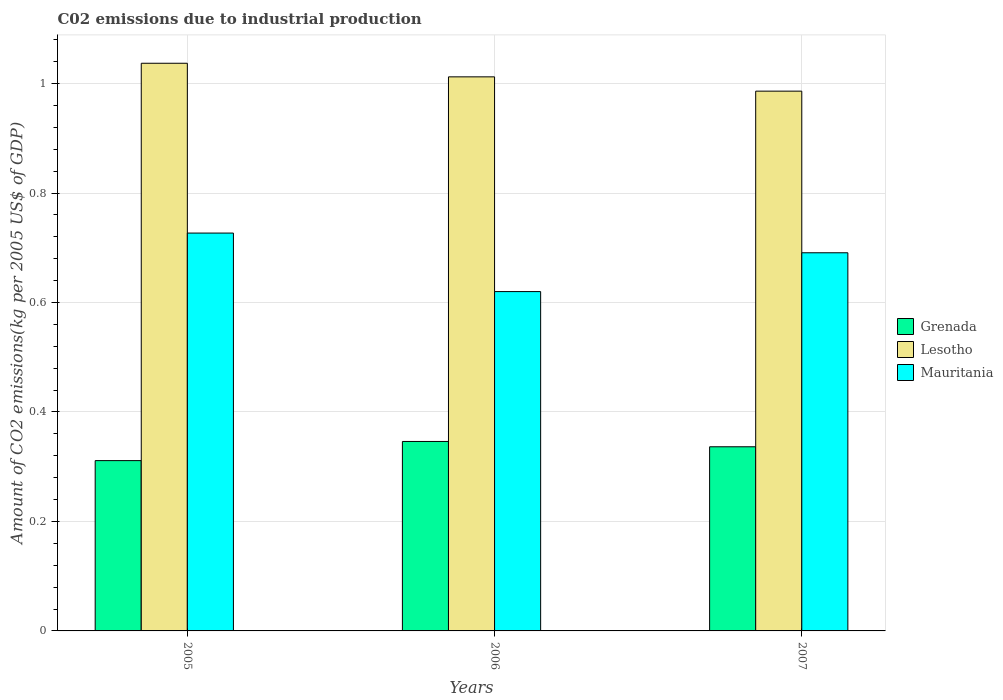How many different coloured bars are there?
Your response must be concise. 3. Are the number of bars on each tick of the X-axis equal?
Your response must be concise. Yes. How many bars are there on the 1st tick from the left?
Your response must be concise. 3. How many bars are there on the 2nd tick from the right?
Offer a terse response. 3. What is the label of the 2nd group of bars from the left?
Offer a terse response. 2006. What is the amount of CO2 emitted due to industrial production in Lesotho in 2006?
Your answer should be compact. 1.01. Across all years, what is the maximum amount of CO2 emitted due to industrial production in Lesotho?
Give a very brief answer. 1.04. Across all years, what is the minimum amount of CO2 emitted due to industrial production in Grenada?
Ensure brevity in your answer.  0.31. In which year was the amount of CO2 emitted due to industrial production in Lesotho maximum?
Your answer should be very brief. 2005. In which year was the amount of CO2 emitted due to industrial production in Grenada minimum?
Provide a succinct answer. 2005. What is the total amount of CO2 emitted due to industrial production in Grenada in the graph?
Provide a short and direct response. 0.99. What is the difference between the amount of CO2 emitted due to industrial production in Lesotho in 2005 and that in 2007?
Your answer should be very brief. 0.05. What is the difference between the amount of CO2 emitted due to industrial production in Lesotho in 2007 and the amount of CO2 emitted due to industrial production in Mauritania in 2005?
Ensure brevity in your answer.  0.26. What is the average amount of CO2 emitted due to industrial production in Grenada per year?
Your answer should be very brief. 0.33. In the year 2005, what is the difference between the amount of CO2 emitted due to industrial production in Grenada and amount of CO2 emitted due to industrial production in Mauritania?
Your answer should be very brief. -0.42. What is the ratio of the amount of CO2 emitted due to industrial production in Grenada in 2006 to that in 2007?
Keep it short and to the point. 1.03. Is the difference between the amount of CO2 emitted due to industrial production in Grenada in 2005 and 2007 greater than the difference between the amount of CO2 emitted due to industrial production in Mauritania in 2005 and 2007?
Offer a very short reply. No. What is the difference between the highest and the second highest amount of CO2 emitted due to industrial production in Grenada?
Your response must be concise. 0.01. What is the difference between the highest and the lowest amount of CO2 emitted due to industrial production in Lesotho?
Provide a succinct answer. 0.05. In how many years, is the amount of CO2 emitted due to industrial production in Grenada greater than the average amount of CO2 emitted due to industrial production in Grenada taken over all years?
Make the answer very short. 2. What does the 1st bar from the left in 2006 represents?
Your answer should be compact. Grenada. What does the 2nd bar from the right in 2007 represents?
Your response must be concise. Lesotho. How many bars are there?
Keep it short and to the point. 9. What is the difference between two consecutive major ticks on the Y-axis?
Offer a very short reply. 0.2. Are the values on the major ticks of Y-axis written in scientific E-notation?
Your answer should be very brief. No. Does the graph contain any zero values?
Offer a terse response. No. What is the title of the graph?
Give a very brief answer. C02 emissions due to industrial production. What is the label or title of the Y-axis?
Make the answer very short. Amount of CO2 emissions(kg per 2005 US$ of GDP). What is the Amount of CO2 emissions(kg per 2005 US$ of GDP) of Grenada in 2005?
Keep it short and to the point. 0.31. What is the Amount of CO2 emissions(kg per 2005 US$ of GDP) in Lesotho in 2005?
Ensure brevity in your answer.  1.04. What is the Amount of CO2 emissions(kg per 2005 US$ of GDP) in Mauritania in 2005?
Your answer should be compact. 0.73. What is the Amount of CO2 emissions(kg per 2005 US$ of GDP) in Grenada in 2006?
Keep it short and to the point. 0.35. What is the Amount of CO2 emissions(kg per 2005 US$ of GDP) in Lesotho in 2006?
Offer a very short reply. 1.01. What is the Amount of CO2 emissions(kg per 2005 US$ of GDP) of Mauritania in 2006?
Provide a succinct answer. 0.62. What is the Amount of CO2 emissions(kg per 2005 US$ of GDP) in Grenada in 2007?
Your answer should be compact. 0.34. What is the Amount of CO2 emissions(kg per 2005 US$ of GDP) of Lesotho in 2007?
Offer a very short reply. 0.99. What is the Amount of CO2 emissions(kg per 2005 US$ of GDP) of Mauritania in 2007?
Offer a very short reply. 0.69. Across all years, what is the maximum Amount of CO2 emissions(kg per 2005 US$ of GDP) in Grenada?
Your answer should be very brief. 0.35. Across all years, what is the maximum Amount of CO2 emissions(kg per 2005 US$ of GDP) in Lesotho?
Offer a terse response. 1.04. Across all years, what is the maximum Amount of CO2 emissions(kg per 2005 US$ of GDP) in Mauritania?
Your response must be concise. 0.73. Across all years, what is the minimum Amount of CO2 emissions(kg per 2005 US$ of GDP) in Grenada?
Your answer should be compact. 0.31. Across all years, what is the minimum Amount of CO2 emissions(kg per 2005 US$ of GDP) in Lesotho?
Your response must be concise. 0.99. Across all years, what is the minimum Amount of CO2 emissions(kg per 2005 US$ of GDP) of Mauritania?
Make the answer very short. 0.62. What is the total Amount of CO2 emissions(kg per 2005 US$ of GDP) in Lesotho in the graph?
Your answer should be compact. 3.04. What is the total Amount of CO2 emissions(kg per 2005 US$ of GDP) of Mauritania in the graph?
Provide a succinct answer. 2.04. What is the difference between the Amount of CO2 emissions(kg per 2005 US$ of GDP) in Grenada in 2005 and that in 2006?
Your answer should be very brief. -0.04. What is the difference between the Amount of CO2 emissions(kg per 2005 US$ of GDP) in Lesotho in 2005 and that in 2006?
Provide a succinct answer. 0.02. What is the difference between the Amount of CO2 emissions(kg per 2005 US$ of GDP) in Mauritania in 2005 and that in 2006?
Give a very brief answer. 0.11. What is the difference between the Amount of CO2 emissions(kg per 2005 US$ of GDP) of Grenada in 2005 and that in 2007?
Offer a terse response. -0.03. What is the difference between the Amount of CO2 emissions(kg per 2005 US$ of GDP) in Lesotho in 2005 and that in 2007?
Give a very brief answer. 0.05. What is the difference between the Amount of CO2 emissions(kg per 2005 US$ of GDP) of Mauritania in 2005 and that in 2007?
Your answer should be compact. 0.04. What is the difference between the Amount of CO2 emissions(kg per 2005 US$ of GDP) in Grenada in 2006 and that in 2007?
Keep it short and to the point. 0.01. What is the difference between the Amount of CO2 emissions(kg per 2005 US$ of GDP) in Lesotho in 2006 and that in 2007?
Provide a short and direct response. 0.03. What is the difference between the Amount of CO2 emissions(kg per 2005 US$ of GDP) of Mauritania in 2006 and that in 2007?
Give a very brief answer. -0.07. What is the difference between the Amount of CO2 emissions(kg per 2005 US$ of GDP) of Grenada in 2005 and the Amount of CO2 emissions(kg per 2005 US$ of GDP) of Lesotho in 2006?
Make the answer very short. -0.7. What is the difference between the Amount of CO2 emissions(kg per 2005 US$ of GDP) of Grenada in 2005 and the Amount of CO2 emissions(kg per 2005 US$ of GDP) of Mauritania in 2006?
Offer a terse response. -0.31. What is the difference between the Amount of CO2 emissions(kg per 2005 US$ of GDP) of Lesotho in 2005 and the Amount of CO2 emissions(kg per 2005 US$ of GDP) of Mauritania in 2006?
Ensure brevity in your answer.  0.42. What is the difference between the Amount of CO2 emissions(kg per 2005 US$ of GDP) of Grenada in 2005 and the Amount of CO2 emissions(kg per 2005 US$ of GDP) of Lesotho in 2007?
Offer a very short reply. -0.68. What is the difference between the Amount of CO2 emissions(kg per 2005 US$ of GDP) in Grenada in 2005 and the Amount of CO2 emissions(kg per 2005 US$ of GDP) in Mauritania in 2007?
Your answer should be very brief. -0.38. What is the difference between the Amount of CO2 emissions(kg per 2005 US$ of GDP) in Lesotho in 2005 and the Amount of CO2 emissions(kg per 2005 US$ of GDP) in Mauritania in 2007?
Your response must be concise. 0.35. What is the difference between the Amount of CO2 emissions(kg per 2005 US$ of GDP) of Grenada in 2006 and the Amount of CO2 emissions(kg per 2005 US$ of GDP) of Lesotho in 2007?
Make the answer very short. -0.64. What is the difference between the Amount of CO2 emissions(kg per 2005 US$ of GDP) in Grenada in 2006 and the Amount of CO2 emissions(kg per 2005 US$ of GDP) in Mauritania in 2007?
Your response must be concise. -0.34. What is the difference between the Amount of CO2 emissions(kg per 2005 US$ of GDP) in Lesotho in 2006 and the Amount of CO2 emissions(kg per 2005 US$ of GDP) in Mauritania in 2007?
Give a very brief answer. 0.32. What is the average Amount of CO2 emissions(kg per 2005 US$ of GDP) of Grenada per year?
Offer a very short reply. 0.33. What is the average Amount of CO2 emissions(kg per 2005 US$ of GDP) of Lesotho per year?
Provide a short and direct response. 1.01. What is the average Amount of CO2 emissions(kg per 2005 US$ of GDP) in Mauritania per year?
Provide a succinct answer. 0.68. In the year 2005, what is the difference between the Amount of CO2 emissions(kg per 2005 US$ of GDP) of Grenada and Amount of CO2 emissions(kg per 2005 US$ of GDP) of Lesotho?
Give a very brief answer. -0.73. In the year 2005, what is the difference between the Amount of CO2 emissions(kg per 2005 US$ of GDP) in Grenada and Amount of CO2 emissions(kg per 2005 US$ of GDP) in Mauritania?
Make the answer very short. -0.42. In the year 2005, what is the difference between the Amount of CO2 emissions(kg per 2005 US$ of GDP) in Lesotho and Amount of CO2 emissions(kg per 2005 US$ of GDP) in Mauritania?
Provide a succinct answer. 0.31. In the year 2006, what is the difference between the Amount of CO2 emissions(kg per 2005 US$ of GDP) in Grenada and Amount of CO2 emissions(kg per 2005 US$ of GDP) in Lesotho?
Your answer should be very brief. -0.67. In the year 2006, what is the difference between the Amount of CO2 emissions(kg per 2005 US$ of GDP) of Grenada and Amount of CO2 emissions(kg per 2005 US$ of GDP) of Mauritania?
Keep it short and to the point. -0.27. In the year 2006, what is the difference between the Amount of CO2 emissions(kg per 2005 US$ of GDP) in Lesotho and Amount of CO2 emissions(kg per 2005 US$ of GDP) in Mauritania?
Ensure brevity in your answer.  0.39. In the year 2007, what is the difference between the Amount of CO2 emissions(kg per 2005 US$ of GDP) of Grenada and Amount of CO2 emissions(kg per 2005 US$ of GDP) of Lesotho?
Offer a very short reply. -0.65. In the year 2007, what is the difference between the Amount of CO2 emissions(kg per 2005 US$ of GDP) of Grenada and Amount of CO2 emissions(kg per 2005 US$ of GDP) of Mauritania?
Your answer should be compact. -0.35. In the year 2007, what is the difference between the Amount of CO2 emissions(kg per 2005 US$ of GDP) of Lesotho and Amount of CO2 emissions(kg per 2005 US$ of GDP) of Mauritania?
Your answer should be very brief. 0.3. What is the ratio of the Amount of CO2 emissions(kg per 2005 US$ of GDP) in Grenada in 2005 to that in 2006?
Offer a terse response. 0.9. What is the ratio of the Amount of CO2 emissions(kg per 2005 US$ of GDP) of Lesotho in 2005 to that in 2006?
Provide a succinct answer. 1.02. What is the ratio of the Amount of CO2 emissions(kg per 2005 US$ of GDP) in Mauritania in 2005 to that in 2006?
Make the answer very short. 1.17. What is the ratio of the Amount of CO2 emissions(kg per 2005 US$ of GDP) in Grenada in 2005 to that in 2007?
Keep it short and to the point. 0.92. What is the ratio of the Amount of CO2 emissions(kg per 2005 US$ of GDP) of Lesotho in 2005 to that in 2007?
Ensure brevity in your answer.  1.05. What is the ratio of the Amount of CO2 emissions(kg per 2005 US$ of GDP) in Mauritania in 2005 to that in 2007?
Offer a very short reply. 1.05. What is the ratio of the Amount of CO2 emissions(kg per 2005 US$ of GDP) in Grenada in 2006 to that in 2007?
Your answer should be compact. 1.03. What is the ratio of the Amount of CO2 emissions(kg per 2005 US$ of GDP) of Lesotho in 2006 to that in 2007?
Ensure brevity in your answer.  1.03. What is the ratio of the Amount of CO2 emissions(kg per 2005 US$ of GDP) in Mauritania in 2006 to that in 2007?
Offer a terse response. 0.9. What is the difference between the highest and the second highest Amount of CO2 emissions(kg per 2005 US$ of GDP) of Grenada?
Your answer should be very brief. 0.01. What is the difference between the highest and the second highest Amount of CO2 emissions(kg per 2005 US$ of GDP) in Lesotho?
Offer a terse response. 0.02. What is the difference between the highest and the second highest Amount of CO2 emissions(kg per 2005 US$ of GDP) of Mauritania?
Ensure brevity in your answer.  0.04. What is the difference between the highest and the lowest Amount of CO2 emissions(kg per 2005 US$ of GDP) of Grenada?
Make the answer very short. 0.04. What is the difference between the highest and the lowest Amount of CO2 emissions(kg per 2005 US$ of GDP) of Lesotho?
Ensure brevity in your answer.  0.05. What is the difference between the highest and the lowest Amount of CO2 emissions(kg per 2005 US$ of GDP) of Mauritania?
Make the answer very short. 0.11. 